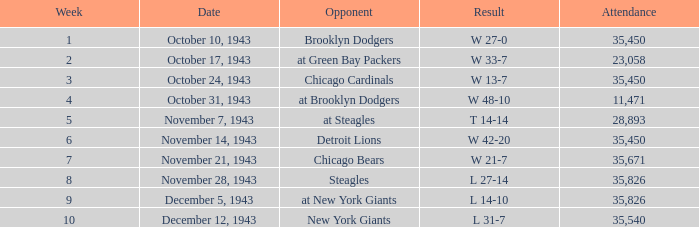In terms of attendance, how many occurrences resulted in w 48-10? 11471.0. 